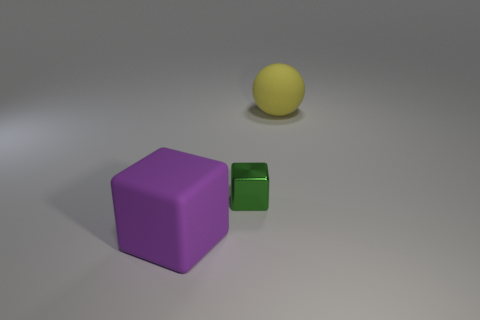Add 3 green balls. How many objects exist? 6 Subtract all cubes. How many objects are left? 1 Add 1 large matte spheres. How many large matte spheres exist? 2 Subtract 0 yellow cubes. How many objects are left? 3 Subtract all green rubber things. Subtract all small green metallic blocks. How many objects are left? 2 Add 1 big yellow things. How many big yellow things are left? 2 